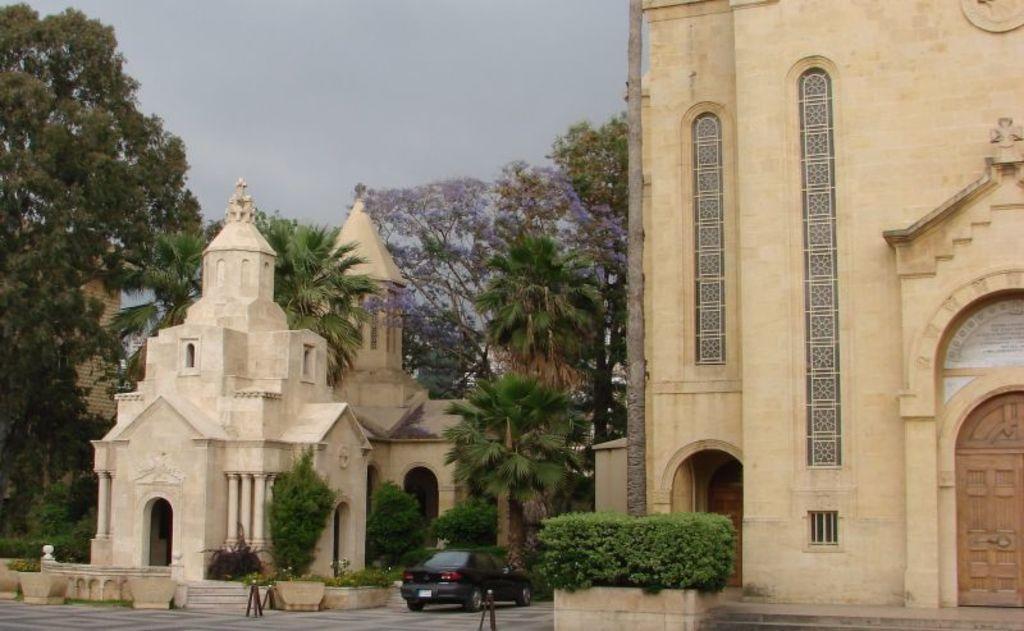In one or two sentences, can you explain what this image depicts? In this picture we can see a car on the ground, poles, concrete planters with plants in it, buildings, trees and in the background we can see the sky. 